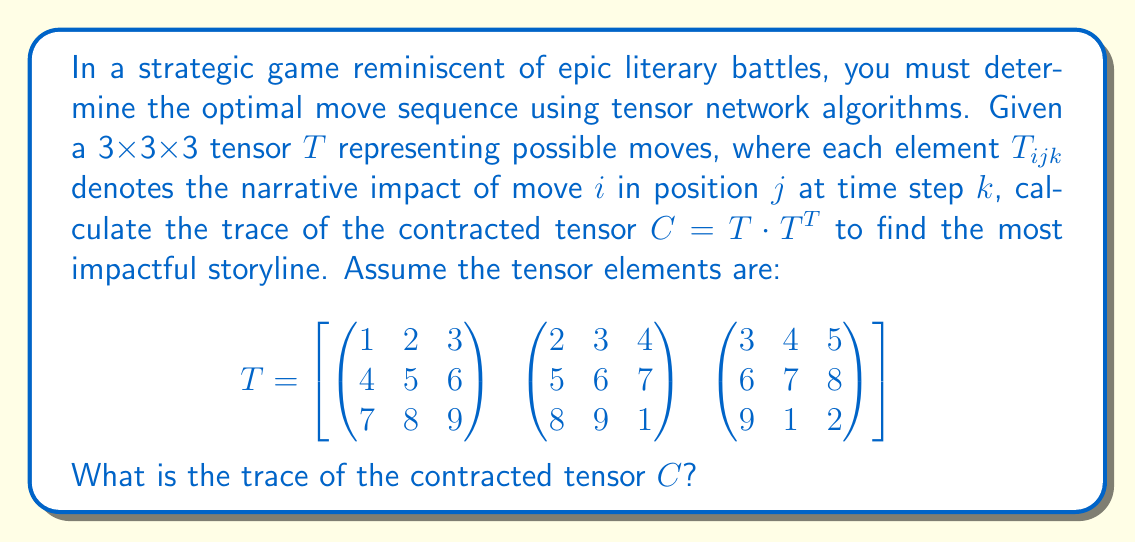Solve this math problem. Let's approach this step-by-step:

1) First, we need to understand what $T \cdot T^T$ means in tensor notation. This is a contraction over two indices, resulting in a 3x3 matrix $C$.

2) The elements of $C$ can be computed as:

   $$C_{ij} = \sum_{k=1}^3 \sum_{l=1}^3 \sum_{m=1}^3 T_{ikl} \cdot T_{jkm}$$

3) To calculate the trace, we only need the diagonal elements of $C$, where $i = j$:

   $$\text{Tr}(C) = \sum_{i=1}^3 C_{ii} = \sum_{i=1}^3 \sum_{k=1}^3 \sum_{l=1}^3 \sum_{m=1}^3 T_{ikl} \cdot T_{ikm}$$

4) Let's calculate each $C_{ii}$:

   For $C_{11}$:
   $$(1^2 + 2^2 + 3^2) + (2^2 + 3^2 + 4^2) + (3^2 + 4^2 + 5^2) = 14 + 29 + 50 = 93$$

   For $C_{22}$:
   $$(4^2 + 5^2 + 6^2) + (5^2 + 6^2 + 7^2) + (6^2 + 7^2 + 8^2) = 77 + 110 + 149 = 336$$

   For $C_{33}$:
   $$(7^2 + 8^2 + 9^2) + (8^2 + 9^2 + 1^2) + (9^2 + 1^2 + 2^2) = 202 + 146 + 86 = 434$$

5) The trace is the sum of these diagonal elements:

   $$\text{Tr}(C) = 93 + 336 + 434 = 863$$

This value represents the overall narrative impact of the optimal move sequence in our strategic game scenario.
Answer: 863 